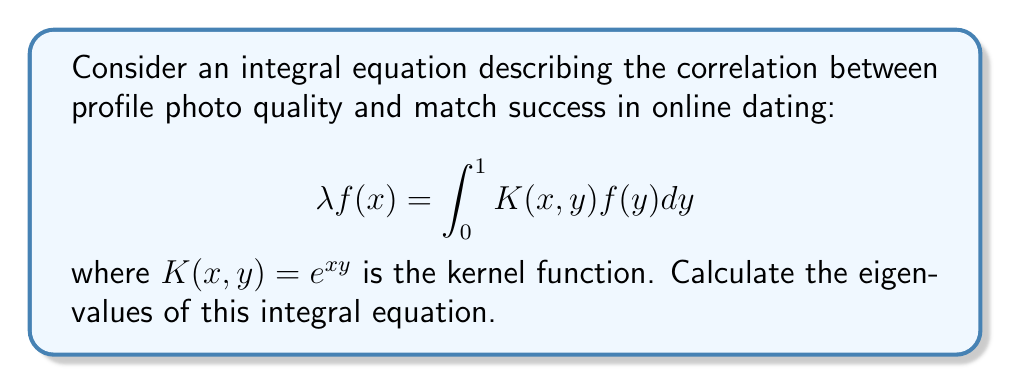Show me your answer to this math problem. To find the eigenvalues, we need to solve the characteristic equation:

1. First, we recognize that this is a separable kernel: $K(x,y) = e^{xy} = e^x \cdot e^y$

2. For separable kernels, we can use the fact that there is only one non-zero eigenvalue, given by:

   $$\lambda = \int_0^1 \int_0^1 K(x,y)dxdy$$

3. Let's calculate this double integral:

   $$\lambda = \int_0^1 \int_0^1 e^{xy}dxdy$$

4. We can solve this by first integrating with respect to x:

   $$\lambda = \int_0^1 \left[\frac{1}{y}e^{xy}\right]_0^1 dy = \int_0^1 \frac{e^y - 1}{y}dy$$

5. This integral is a special function known as the exponential integral. It can be expressed as:

   $$\lambda = Ei(1) - \gamma$$

   where $Ei(1)$ is the exponential integral evaluated at 1, and $\gamma$ is the Euler-Mascheroni constant.

6. The numerical value of this eigenvalue is approximately 1.4616321449683623...

Therefore, the only non-zero eigenvalue of this integral equation is $\lambda \approx 1.4616$.
Answer: $\lambda \approx 1.4616$ 